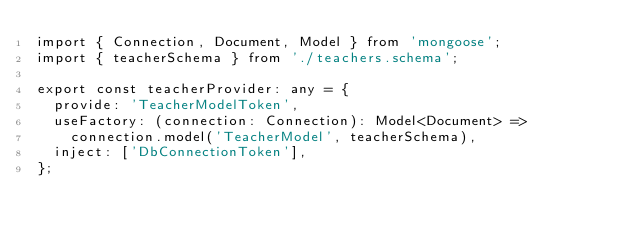Convert code to text. <code><loc_0><loc_0><loc_500><loc_500><_TypeScript_>import { Connection, Document, Model } from 'mongoose';
import { teacherSchema } from './teachers.schema';

export const teacherProvider: any = {
  provide: 'TeacherModelToken',
  useFactory: (connection: Connection): Model<Document> =>
    connection.model('TeacherModel', teacherSchema),
  inject: ['DbConnectionToken'],
};
</code> 